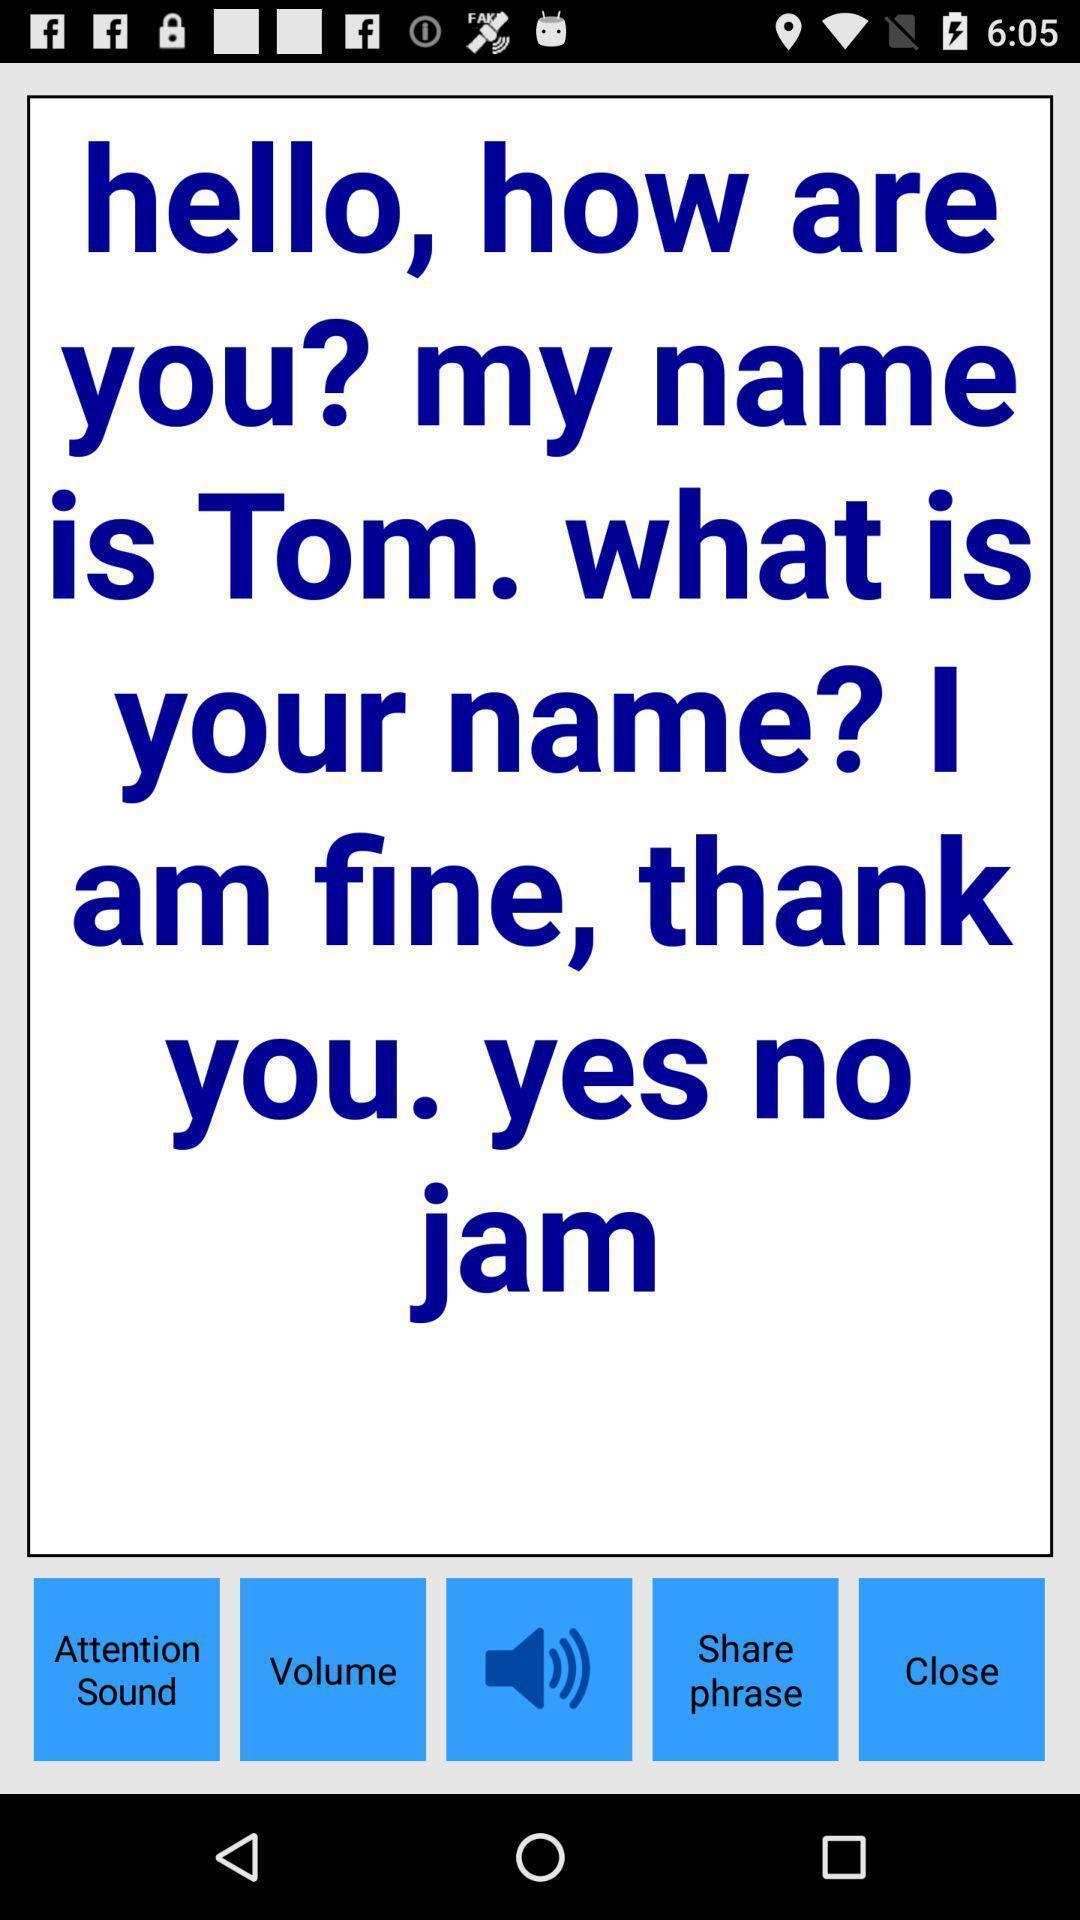What is the overall content of this screenshot? Page shows to listen sentence in the learning app. 